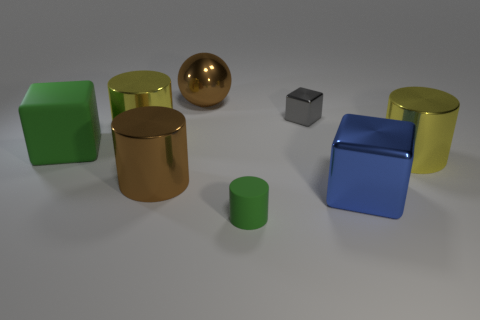Does the rubber cylinder have the same color as the big cube that is left of the tiny rubber cylinder?
Your answer should be compact. Yes. How many cubes are either brown objects or big green things?
Offer a very short reply. 1. What is the color of the small thing that is on the left side of the small gray block?
Make the answer very short. Green. There is a object that is the same color as the ball; what is its shape?
Give a very brief answer. Cylinder. How many yellow metal cylinders are the same size as the blue cube?
Your answer should be compact. 2. Does the yellow object that is left of the big brown metal ball have the same shape as the big yellow metal thing on the right side of the large brown metallic cylinder?
Provide a short and direct response. Yes. What material is the small gray object that is on the left side of the yellow metallic thing on the right side of the brown object that is in front of the green block?
Offer a very short reply. Metal. The other object that is the same size as the gray thing is what shape?
Your answer should be very brief. Cylinder. Are there any cylinders of the same color as the metallic ball?
Offer a very short reply. Yes. The blue thing has what size?
Your response must be concise. Large. 